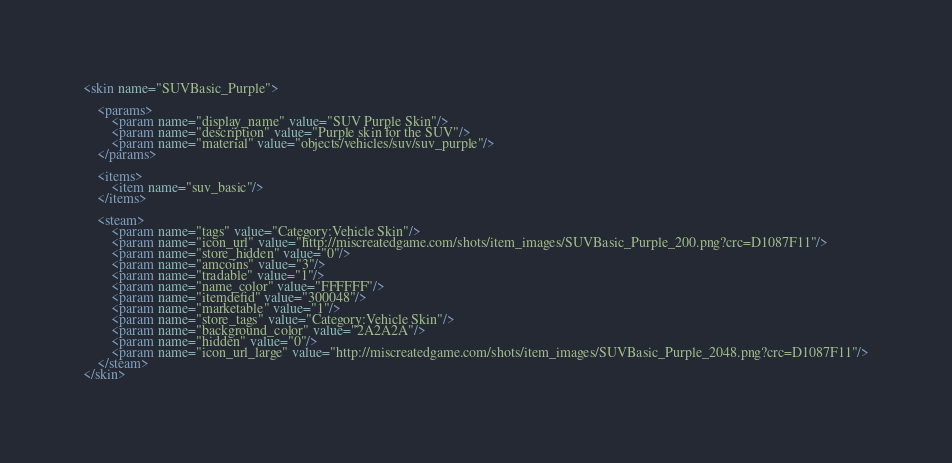Convert code to text. <code><loc_0><loc_0><loc_500><loc_500><_XML_><skin name="SUVBasic_Purple">

	<params>
		<param name="display_name" value="SUV Purple Skin"/>
		<param name="description" value="Purple skin for the SUV"/>
		<param name="material" value="objects/vehicles/suv/suv_purple"/>
	</params>

	<items>
		<item name="suv_basic"/>
	</items>

	<steam>
		<param name="tags" value="Category:Vehicle Skin"/>
		<param name="icon_url" value="http://miscreatedgame.com/shots/item_images/SUVBasic_Purple_200.png?crc=D1087F11"/>
		<param name="store_hidden" value="0"/>
		<param name="amcoins" value="3"/>
		<param name="tradable" value="1"/>
		<param name="name_color" value="FFFFFF"/>
		<param name="itemdefid" value="300048"/>
		<param name="marketable" value="1"/>
		<param name="store_tags" value="Category:Vehicle Skin"/>
		<param name="background_color" value="2A2A2A"/>
		<param name="hidden" value="0"/>
		<param name="icon_url_large" value="http://miscreatedgame.com/shots/item_images/SUVBasic_Purple_2048.png?crc=D1087F11"/>
	</steam>
</skin></code> 